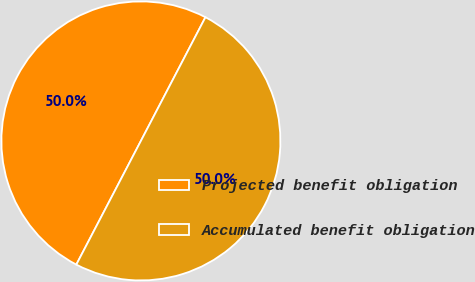<chart> <loc_0><loc_0><loc_500><loc_500><pie_chart><fcel>Projected benefit obligation<fcel>Accumulated benefit obligation<nl><fcel>50.0%<fcel>50.0%<nl></chart> 